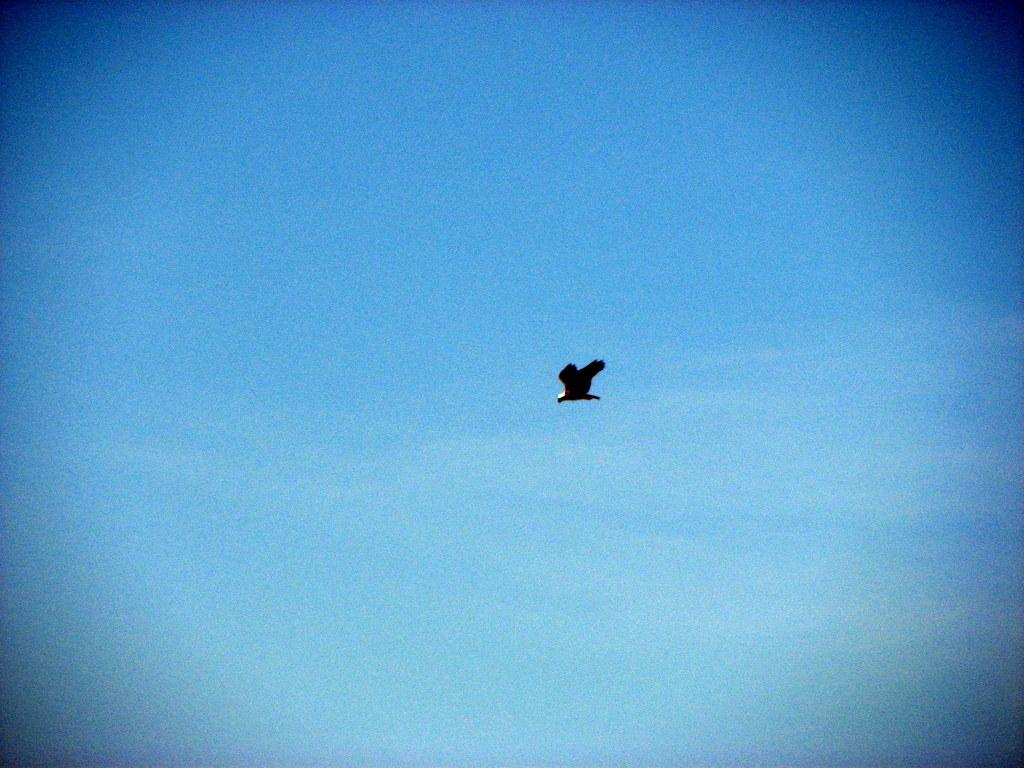What type of animal can be seen in the image? There is a bird in the image. What is the bird doing in the image? The bird is flying in the air. What part of the natural environment is visible in the image? The sky is visible in the image. What color is the sky in the image? The sky is blue in the image. How many members are in the bird's family in the image? There is no information about the bird's family in the image, so it cannot be determined. 